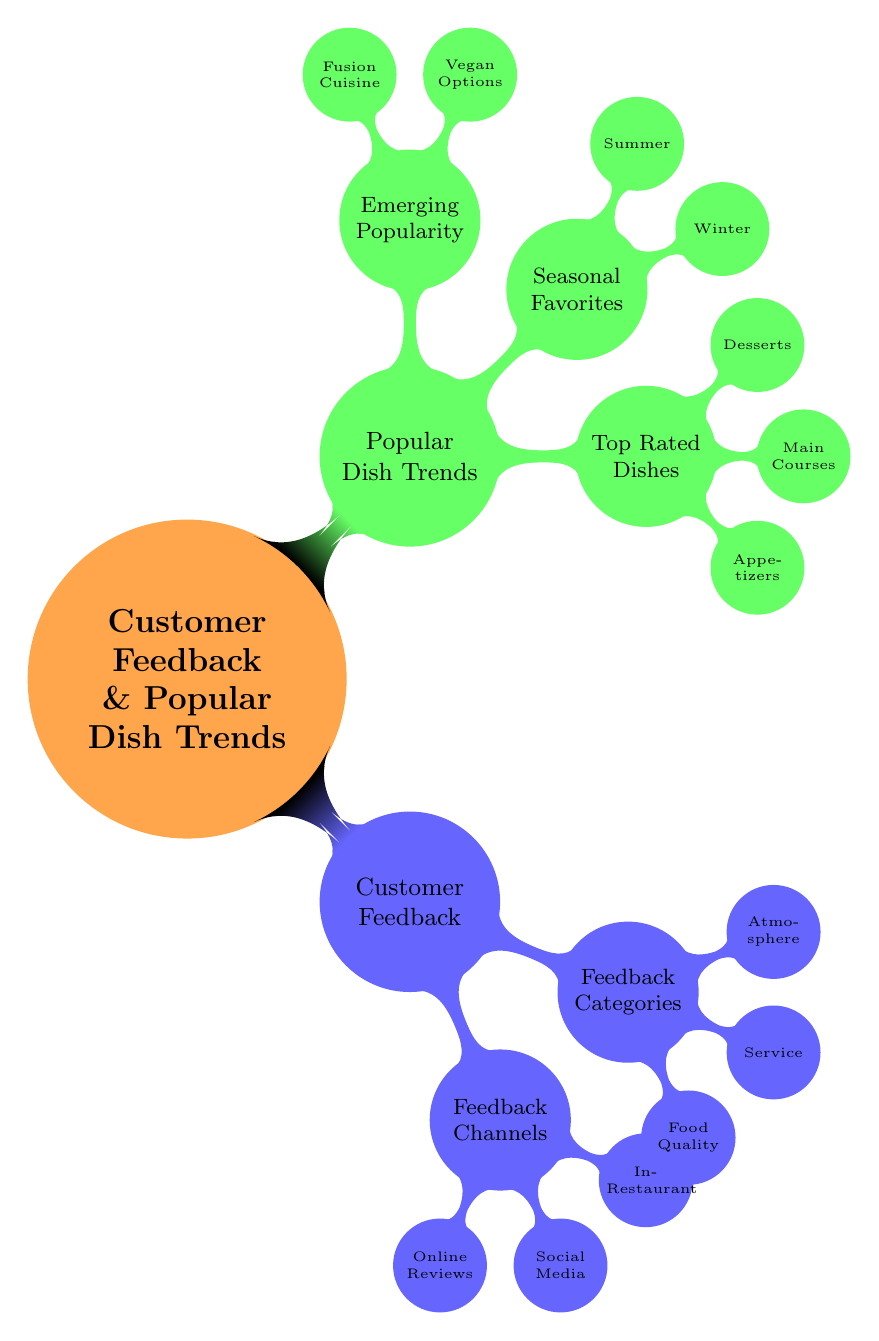What are the two main branches in the diagram? The top-level nodes of the mind map represent two main themes: "Customer Feedback" and "Popular Dish Trends." These branches are the primary focus of the diagram.
Answer: Customer Feedback and Popular Dish Trends How many feedback channels are listed under Customer Feedback? The node "Feedback Channels" has three sub-nodes: "Online Reviews," "Social Media," and "In-Restaurant Surveys." Counting these gives a total of three feedback channels.
Answer: 3 What is one category of feedback listed in the diagram? The node "Feedback Categories" includes several categories, one of which is "Food Quality." This shows the types of feedback that can be categorized under it.
Answer: Food Quality Which dish is mentioned as a seasonal favorite for winter? The "Seasonal Favorites" node contains two sub-nodes, one of which lists "Beef Stew" as a winter dish. This indicates that it is a popular choice during the winter season.
Answer: Beef Stew What type of dishes are featured under Top Rated Dishes? Under "Top Rated Dishes," there are three types of dishes: "Appetizers," "Main Courses," and "Desserts." This categorizes the popular dishes into these distinct types.
Answer: Appetizers, Main Courses, Desserts How many types of emerging popularity dishes are identified? The "Emerging Popularity" branch has two sub-nodes: "Vegan Options" and "Fusion Cuisine." Counting these gives us a total of two types of emerging dishes.
Answer: 2 Which social media platform is mentioned as a feedback channel? The "Feedback Channels" node lists "Social Media," and one of the specific platforms under it is "Instagram." This indicates the use of social media for gathering feedback.
Answer: Instagram What popular dish is listed as an appetizer? Under the "Top Rated Dishes" section, "Bruschetta" is explicitly mentioned as an appetizer. This categorizes it within the popular dishes served.
Answer: Bruschetta What feedback category addresses the cleanliness of the restaurant? The feedback that pertains to the cleanliness of the restaurant falls under the "Atmosphere" category, highlighting that it is one of the aspects inspired by customer feedback.
Answer: Atmosphere 